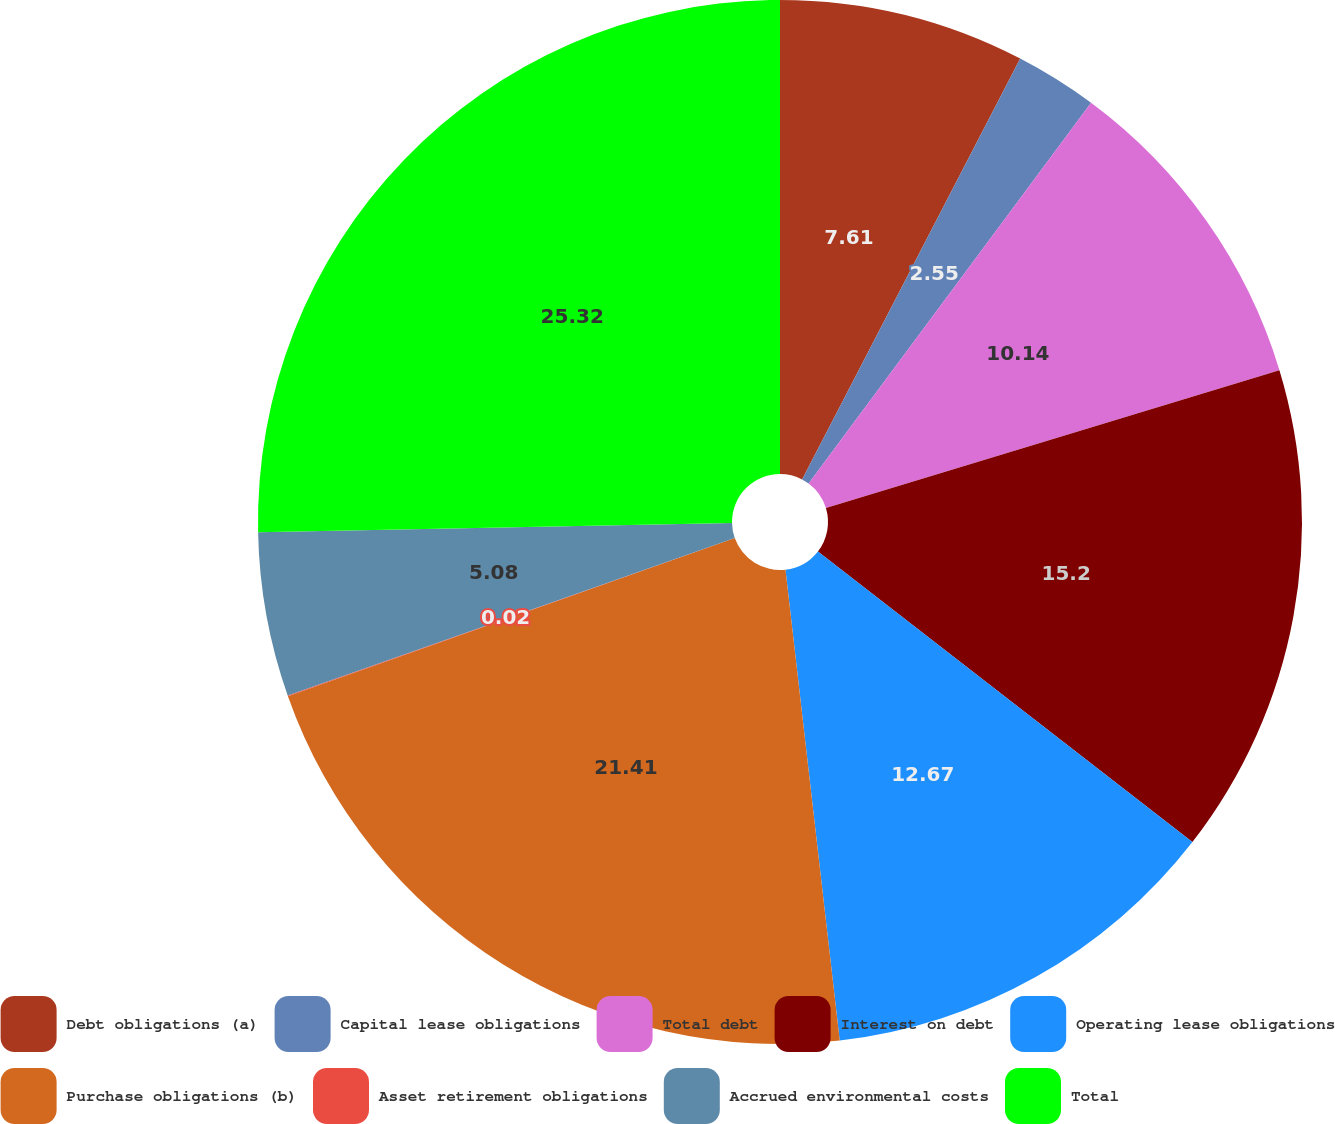<chart> <loc_0><loc_0><loc_500><loc_500><pie_chart><fcel>Debt obligations (a)<fcel>Capital lease obligations<fcel>Total debt<fcel>Interest on debt<fcel>Operating lease obligations<fcel>Purchase obligations (b)<fcel>Asset retirement obligations<fcel>Accrued environmental costs<fcel>Total<nl><fcel>7.61%<fcel>2.55%<fcel>10.14%<fcel>15.2%<fcel>12.67%<fcel>21.41%<fcel>0.02%<fcel>5.08%<fcel>25.31%<nl></chart> 